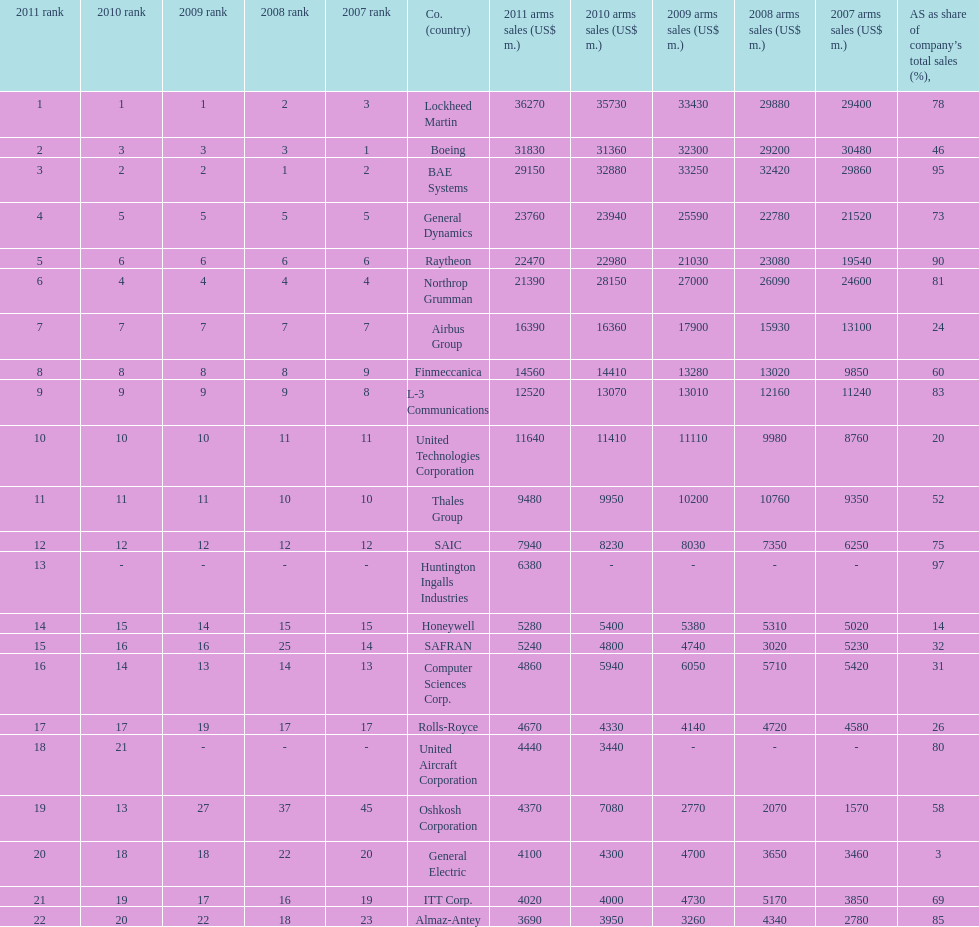Which is the only company to have under 10% arms sales as share of company's total sales? General Electric. 